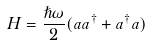<formula> <loc_0><loc_0><loc_500><loc_500>H = \frac { \hslash \omega } { 2 } ( a a ^ { \dagger } + a ^ { \dagger } a ) \</formula> 